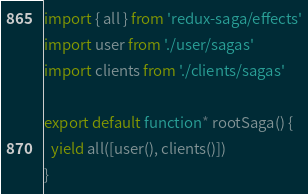<code> <loc_0><loc_0><loc_500><loc_500><_JavaScript_>import { all } from 'redux-saga/effects'
import user from './user/sagas'
import clients from './clients/sagas'

export default function* rootSaga() {
  yield all([user(), clients()])
}
</code> 